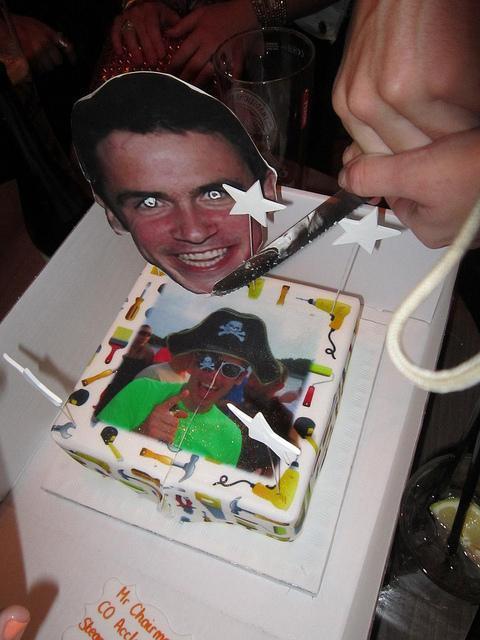How many people can be seen?
Give a very brief answer. 4. How many boats are there?
Give a very brief answer. 0. 